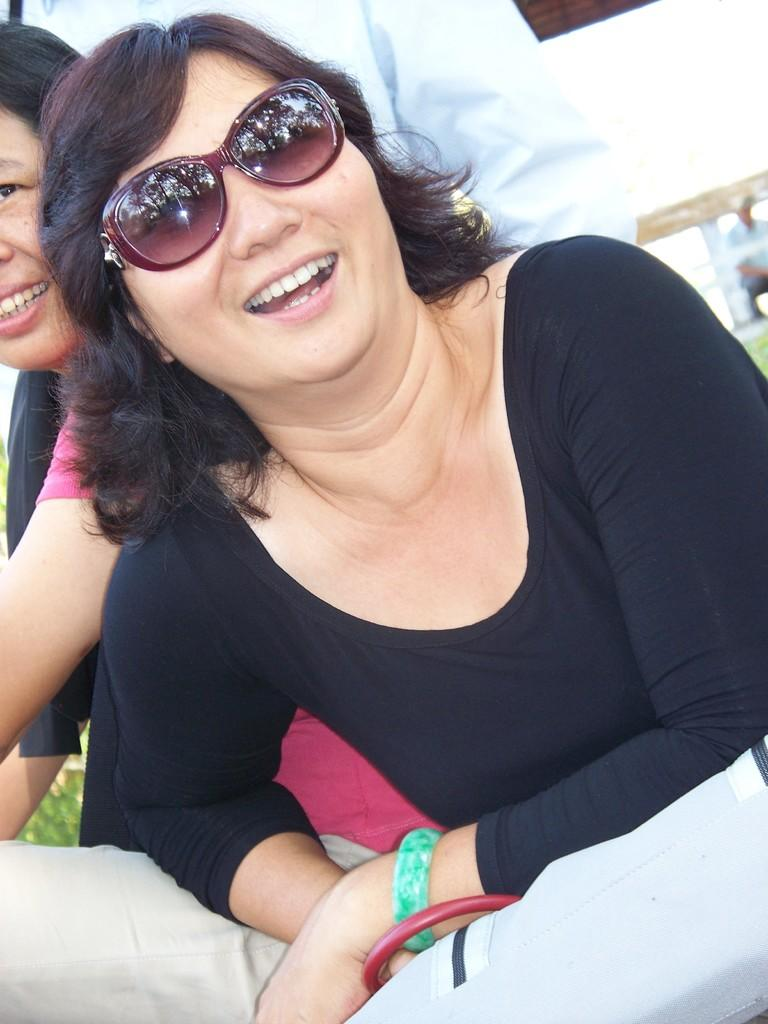How many women are in the image? There are two women in the image. What is the facial expression of the women? Both women are smiling. What is one of the women wearing? One of the women is wearing goggles. Can you describe the other person visible in the image? There is another person visible in the image behind the two women, but no specific details are provided about this person. What type of polish is the woman applying to her nails in the image? There is no indication in the image that either woman is applying polish to their nails. Can you see any bats flying in the background of the image? There is no mention of bats or any other animals in the image. 